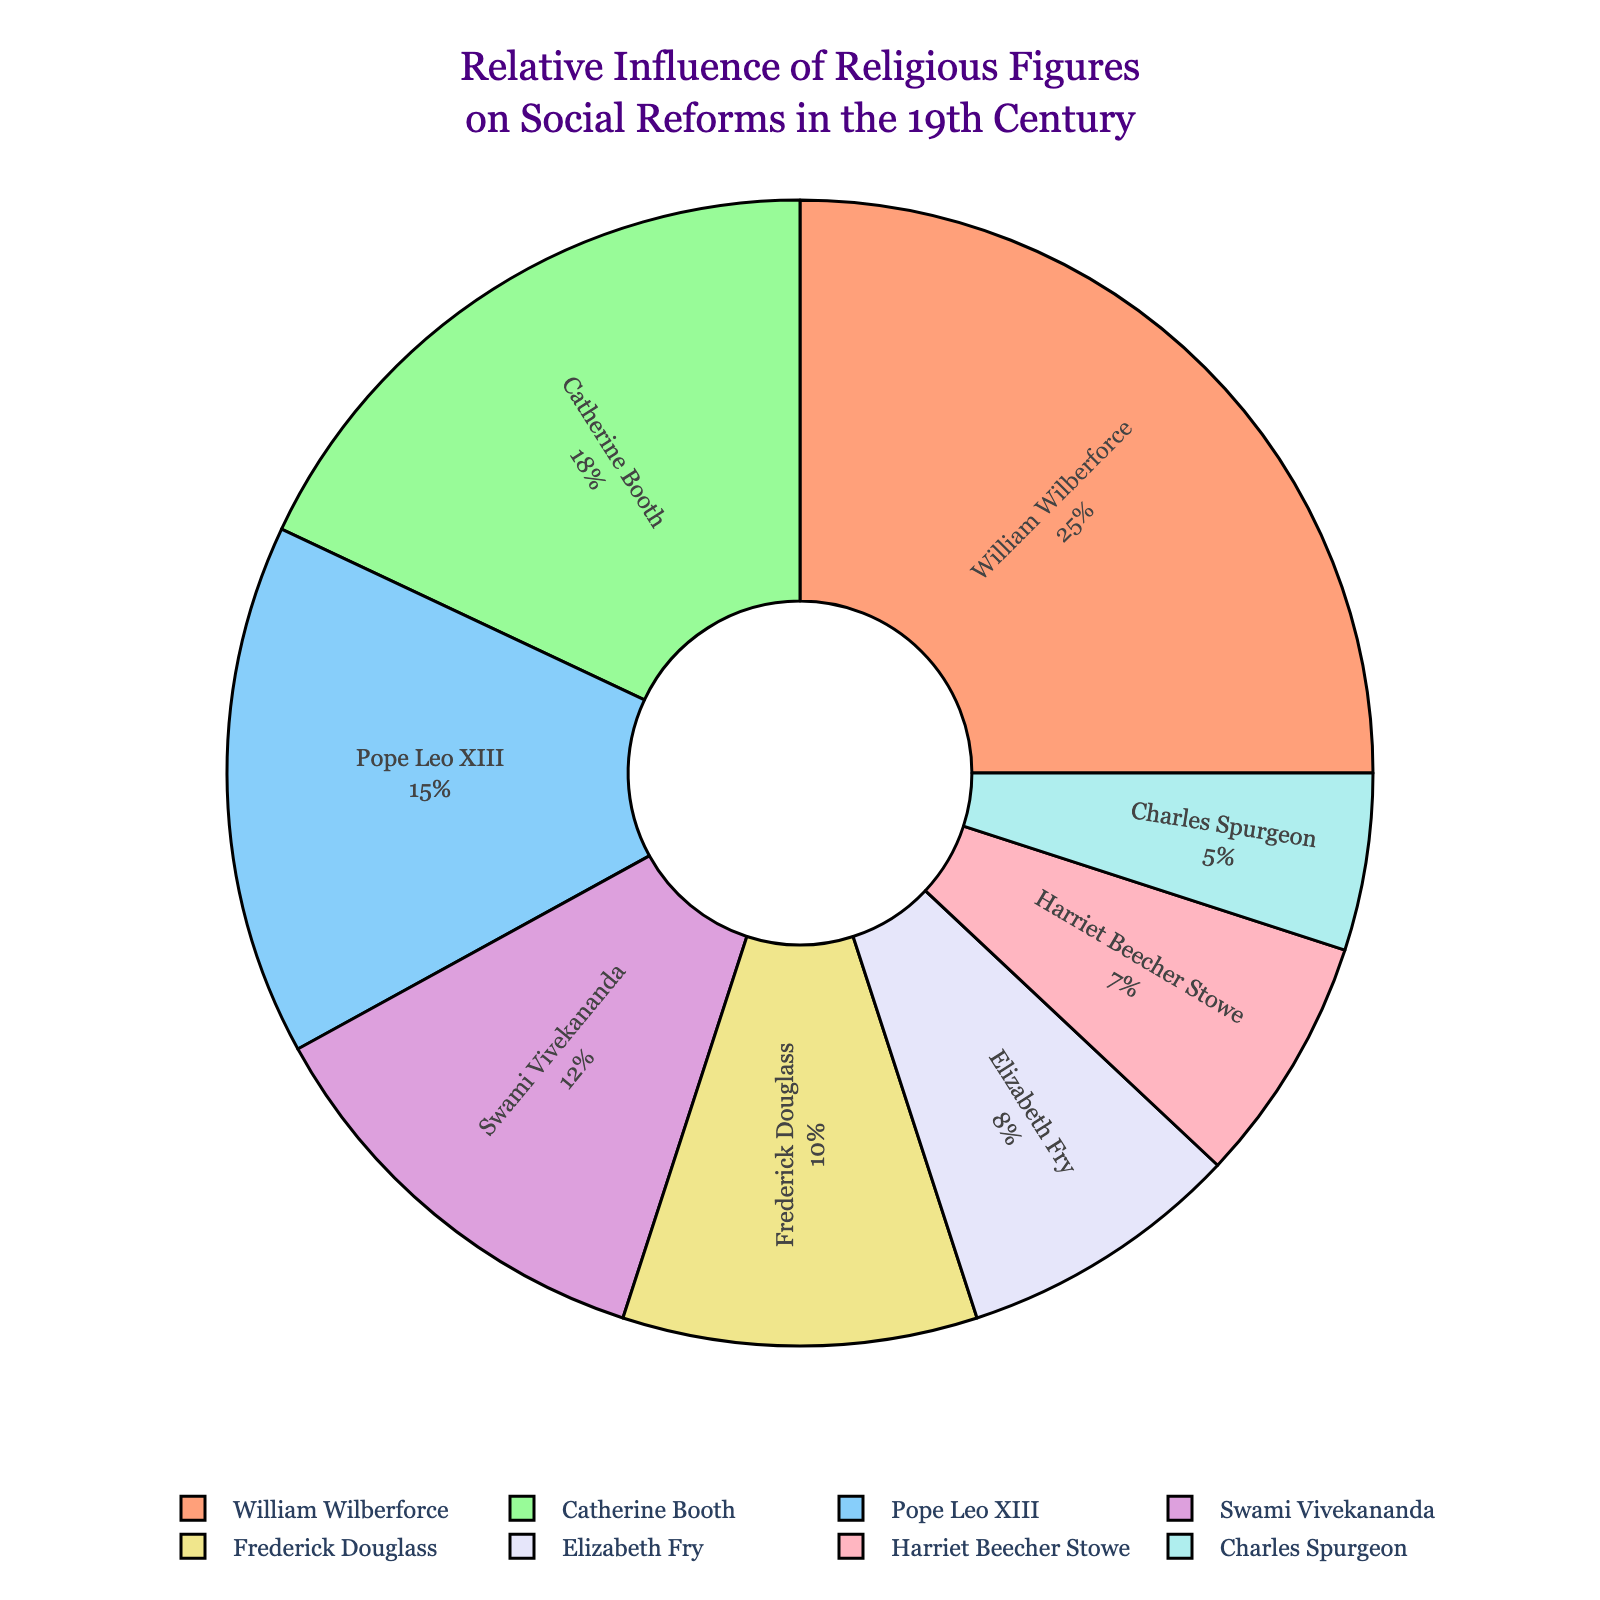Which religious figure has the highest influence percentage? William Wilberforce has the highest influence percentage as indicated by the largest portion of the pie chart and the label showing 25%.
Answer: William Wilberforce Who has a greater influence, Catherine Booth or Swami Vivekananda? By comparing the percentages shown on the pie chart, Catherine Booth has 18% while Swami Vivekananda has 12%. Therefore, Catherine Booth has a greater influence.
Answer: Catherine Booth What is the combined influence of Frederick Douglass, Elizabeth Fry, and Harriet Beecher Stowe? Sum the influence percentages of Frederick Douglass (10%), Elizabeth Fry (8%), and Harriet Beecher Stowe (7%). Therefore, 10% + 8% + 7% = 25%.
Answer: 25% How much more influence does William Wilberforce have compared to Charles Spurgeon? Subtract Charles Spurgeon's influence percentage (5%) from William Wilberforce's (25%). Therefore, 25% - 5% = 20%.
Answer: 20% What percentage of influence is shared by the three least influential figures? Sum the influence percentages of the three least influential figures, which are Harriet Beecher Stowe (7%), Charles Spurgeon (5%), and Elizabeth Fry (8%). Therefore, 7% + 5% + 8% = 20%.
Answer: 20% Which figure is represented in purple, and what is their influence percentage? The figure represented in purple is Swami Vivekananda, and his influence percentage is 12%, as indicated by the color legend and the corresponding slice of the pie chart.
Answer: Swami Vivekananda, 12% What is the difference in influence percentage between Pope Leo XIII and Harriet Beecher Stowe? Subtract Harriet Beecher Stowe's influence percentage (7%) from Pope Leo XIII's (15%). Therefore, 15% - 7% = 8%.
Answer: 8% Who are the religious figures with an influence percentage above 15%? Identifying the figures with percentages above 15% includes William Wilberforce (25%) and Catherine Booth (18%) as shown in the chart.
Answer: William Wilberforce, Catherine Booth What is the total influence percentage of all figures combined? Sum the influence percentages of all figures: 25% (William Wilberforce) + 18% (Catherine Booth) + 15% (Pope Leo XIII) + 12% (Swami Vivekananda) + 10% (Frederick Douglass) + 8% (Elizabeth Fry) + 7% (Harriet Beecher Stowe) + 5% (Charles Spurgeon) = 100%.
Answer: 100% 